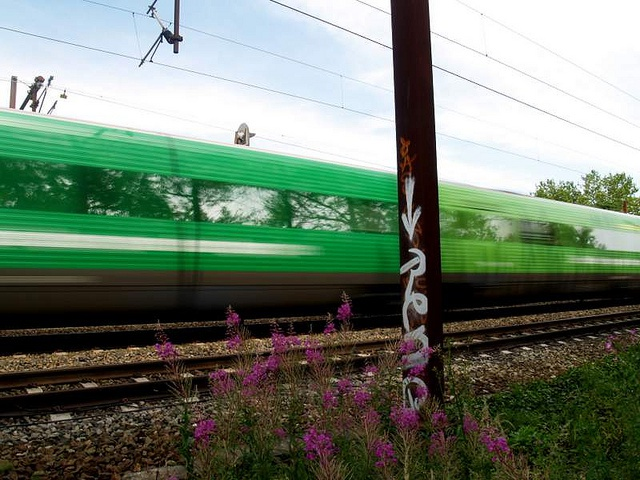Describe the objects in this image and their specific colors. I can see a train in lightblue, black, darkgreen, green, and lightgreen tones in this image. 